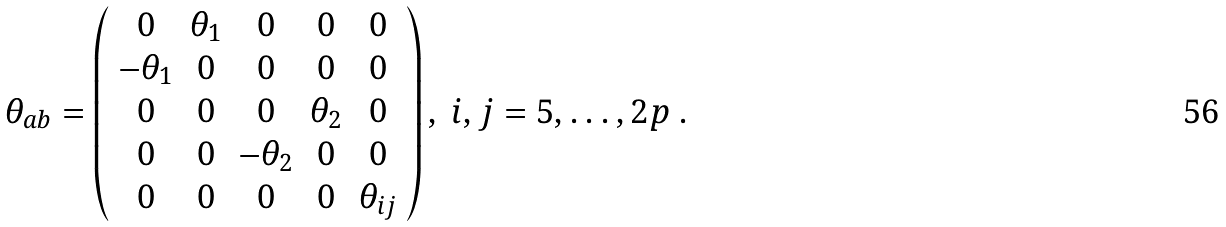<formula> <loc_0><loc_0><loc_500><loc_500>\theta _ { a b } = \left ( \begin{array} { c c c c c } 0 & \theta _ { 1 } & 0 & 0 & 0 \\ - \theta _ { 1 } & 0 & 0 & 0 & 0 \\ 0 & 0 & 0 & \theta _ { 2 } & 0 \\ 0 & 0 & - \theta _ { 2 } & 0 & 0 \\ 0 & 0 & 0 & 0 & \theta _ { i j } \\ \end{array} \right ) , \ i , j = 5 , \dots , 2 p \ .</formula> 